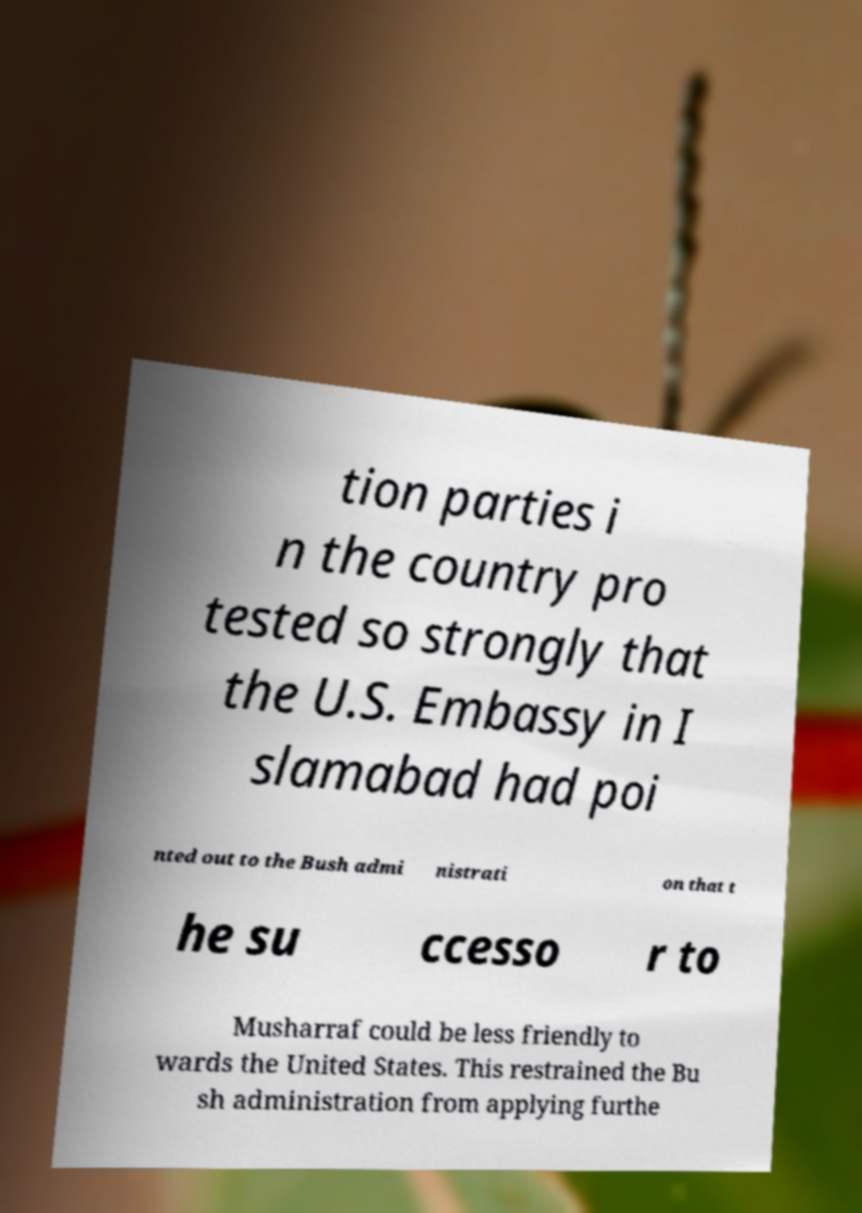Can you read and provide the text displayed in the image?This photo seems to have some interesting text. Can you extract and type it out for me? tion parties i n the country pro tested so strongly that the U.S. Embassy in I slamabad had poi nted out to the Bush admi nistrati on that t he su ccesso r to Musharraf could be less friendly to wards the United States. This restrained the Bu sh administration from applying furthe 